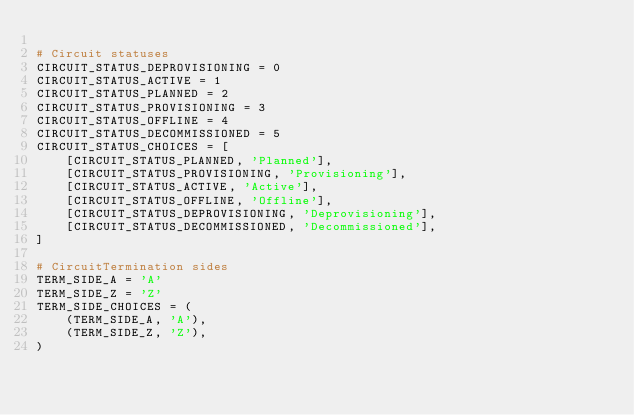Convert code to text. <code><loc_0><loc_0><loc_500><loc_500><_Python_>
# Circuit statuses
CIRCUIT_STATUS_DEPROVISIONING = 0
CIRCUIT_STATUS_ACTIVE = 1
CIRCUIT_STATUS_PLANNED = 2
CIRCUIT_STATUS_PROVISIONING = 3
CIRCUIT_STATUS_OFFLINE = 4
CIRCUIT_STATUS_DECOMMISSIONED = 5
CIRCUIT_STATUS_CHOICES = [
    [CIRCUIT_STATUS_PLANNED, 'Planned'],
    [CIRCUIT_STATUS_PROVISIONING, 'Provisioning'],
    [CIRCUIT_STATUS_ACTIVE, 'Active'],
    [CIRCUIT_STATUS_OFFLINE, 'Offline'],
    [CIRCUIT_STATUS_DEPROVISIONING, 'Deprovisioning'],
    [CIRCUIT_STATUS_DECOMMISSIONED, 'Decommissioned'],
]

# CircuitTermination sides
TERM_SIDE_A = 'A'
TERM_SIDE_Z = 'Z'
TERM_SIDE_CHOICES = (
    (TERM_SIDE_A, 'A'),
    (TERM_SIDE_Z, 'Z'),
)
</code> 